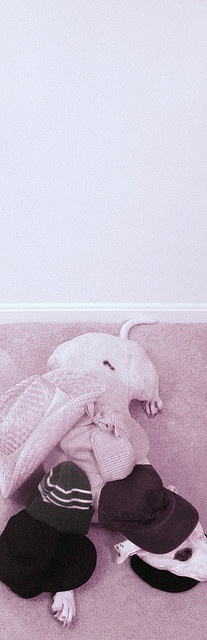Describe the objects in this image and their specific colors. I can see dog in lavender, pink, and lightpink tones and dog in lavender, black, and pink tones in this image. 